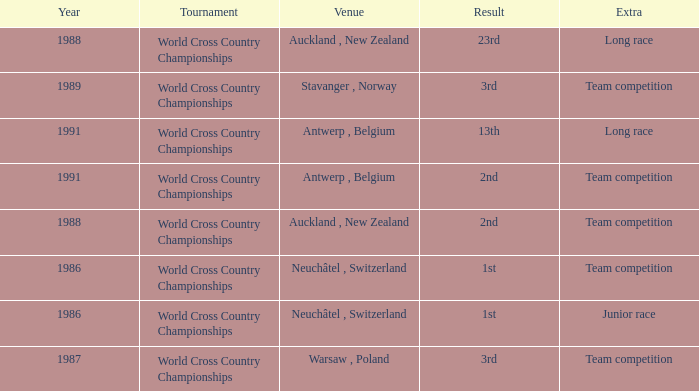Which venue had an extra of Team Competition and a result of 1st? Neuchâtel , Switzerland. 